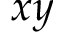<formula> <loc_0><loc_0><loc_500><loc_500>x y</formula> 